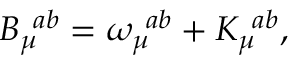<formula> <loc_0><loc_0><loc_500><loc_500>B _ { \mu } ^ { \, a b } = \omega _ { \mu } ^ { \, a b } + K _ { \mu } ^ { \, a b } ,</formula> 